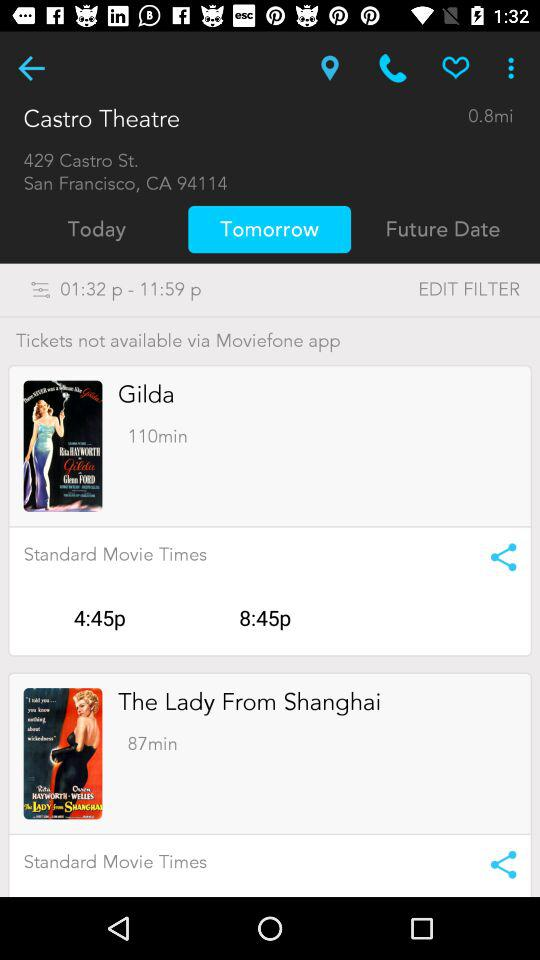How many movies are playing at the Castro Theatre?
Answer the question using a single word or phrase. 2 